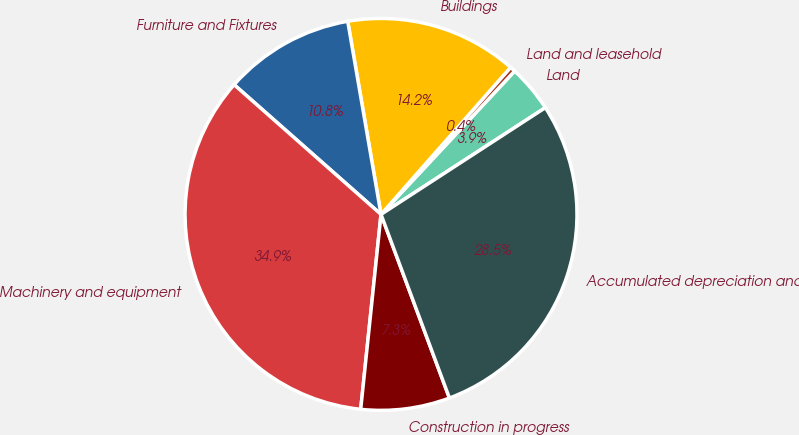Convert chart. <chart><loc_0><loc_0><loc_500><loc_500><pie_chart><fcel>Land<fcel>Land and leasehold<fcel>Buildings<fcel>Furniture and Fixtures<fcel>Machinery and equipment<fcel>Construction in progress<fcel>Accumulated depreciation and<nl><fcel>3.89%<fcel>0.45%<fcel>14.21%<fcel>10.77%<fcel>34.86%<fcel>7.33%<fcel>28.49%<nl></chart> 